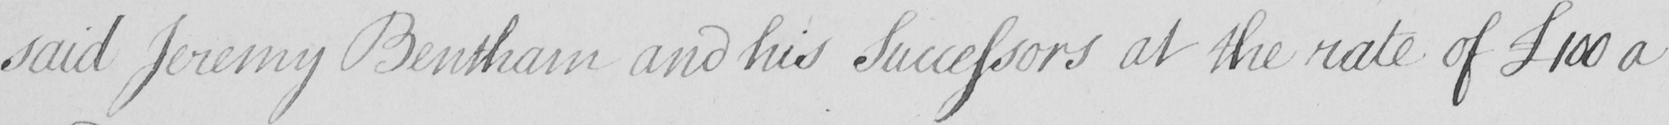Please transcribe the handwritten text in this image. said Jeremy Bentham and his Successors at the rate of  £100 a 